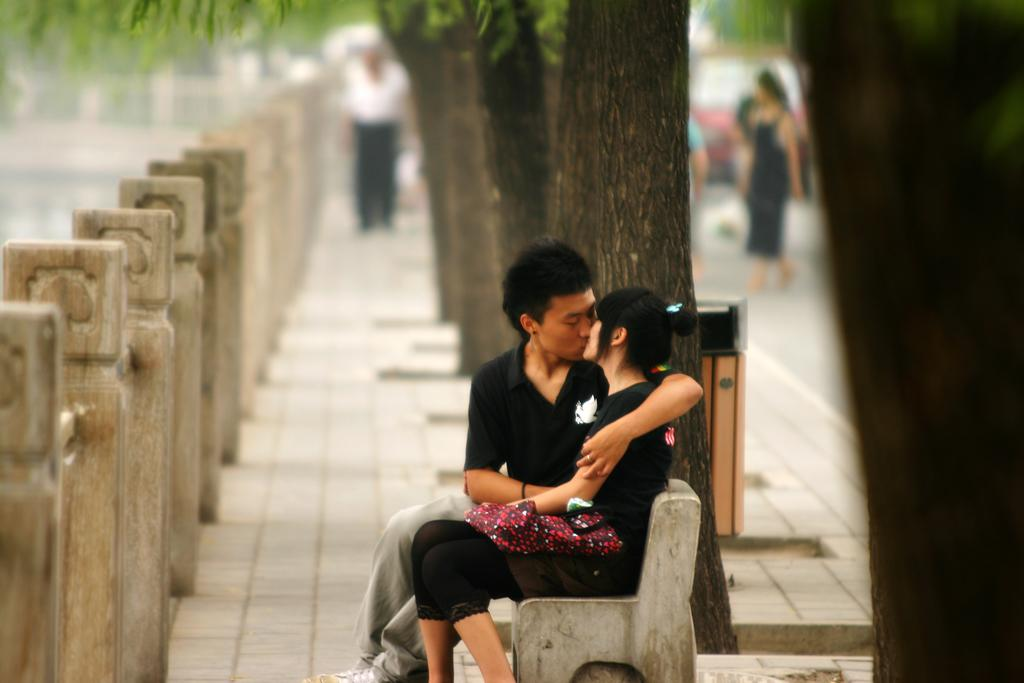How many people are sitting on the bench in the image? There are two persons sitting on a bench in the image. What are the two persons doing on the bench? The two persons are kissing. What can be seen in the background of the image? There are trees visible in the background, as well as a group of persons standing and cars traveling on the road. What type of chair is the blood spilled on in the image? There is no chair or blood present in the image. 